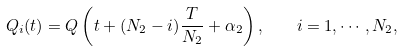Convert formula to latex. <formula><loc_0><loc_0><loc_500><loc_500>Q _ { i } ( t ) = Q \left ( t + ( N _ { 2 } - i ) \frac { T } { N _ { 2 } } + \alpha _ { 2 } \right ) , \quad i = 1 , \cdots , N _ { 2 } ,</formula> 